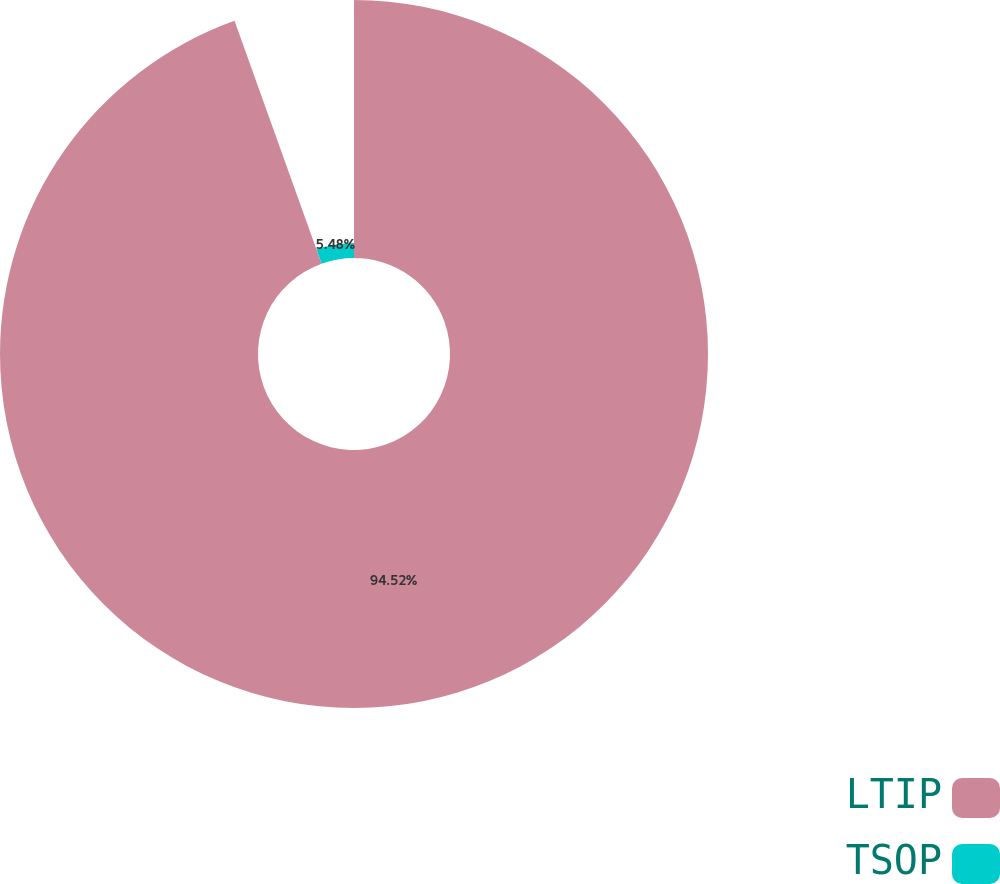Convert chart. <chart><loc_0><loc_0><loc_500><loc_500><pie_chart><fcel>LTIP<fcel>TSOP<nl><fcel>94.52%<fcel>5.48%<nl></chart> 